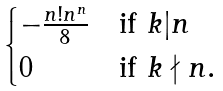<formula> <loc_0><loc_0><loc_500><loc_500>\begin{cases} - \frac { n ! n ^ { n } } { 8 } & \text {if } k | n \\ 0 & \text {if } k \nmid n . \end{cases}</formula> 